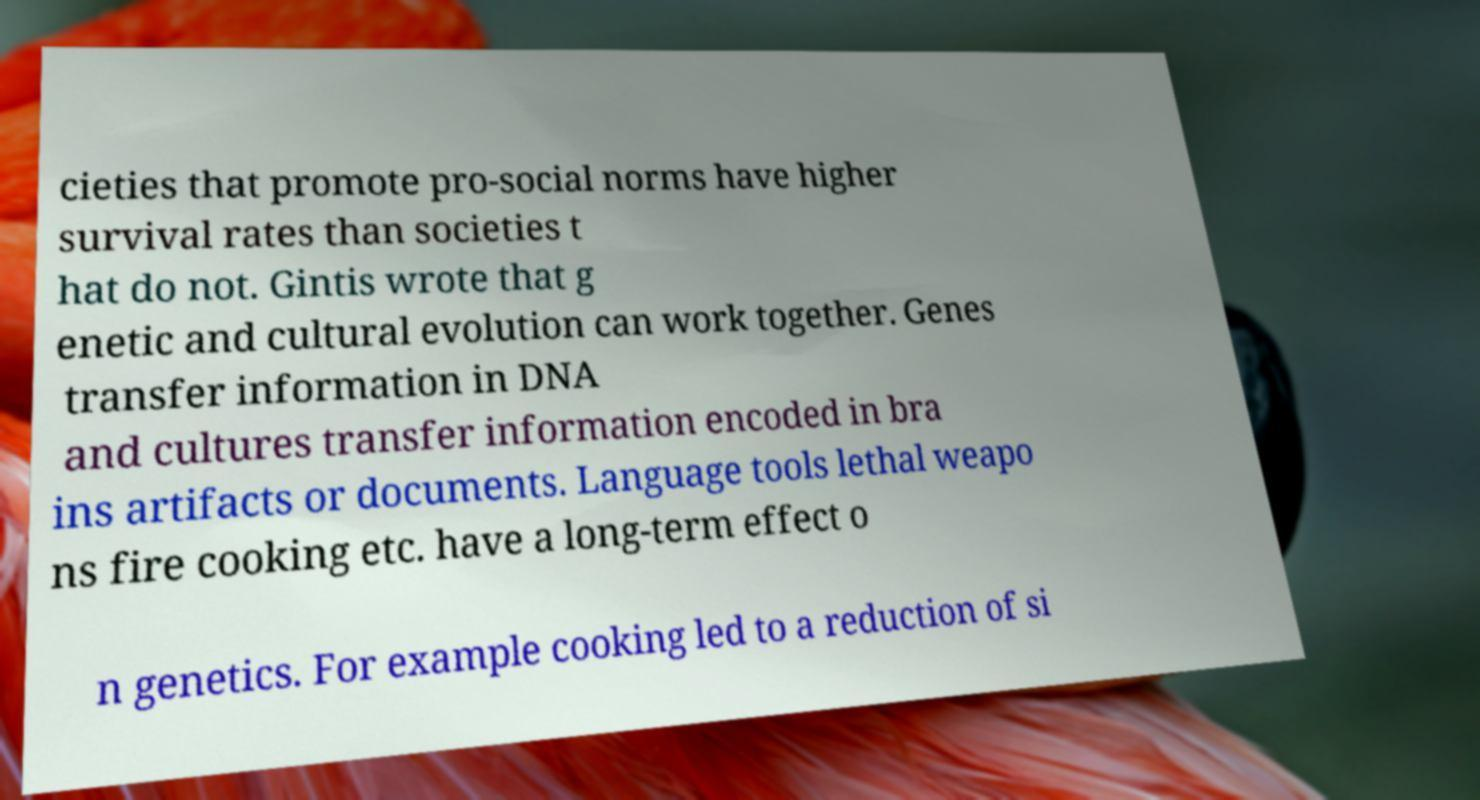I need the written content from this picture converted into text. Can you do that? cieties that promote pro-social norms have higher survival rates than societies t hat do not. Gintis wrote that g enetic and cultural evolution can work together. Genes transfer information in DNA and cultures transfer information encoded in bra ins artifacts or documents. Language tools lethal weapo ns fire cooking etc. have a long-term effect o n genetics. For example cooking led to a reduction of si 